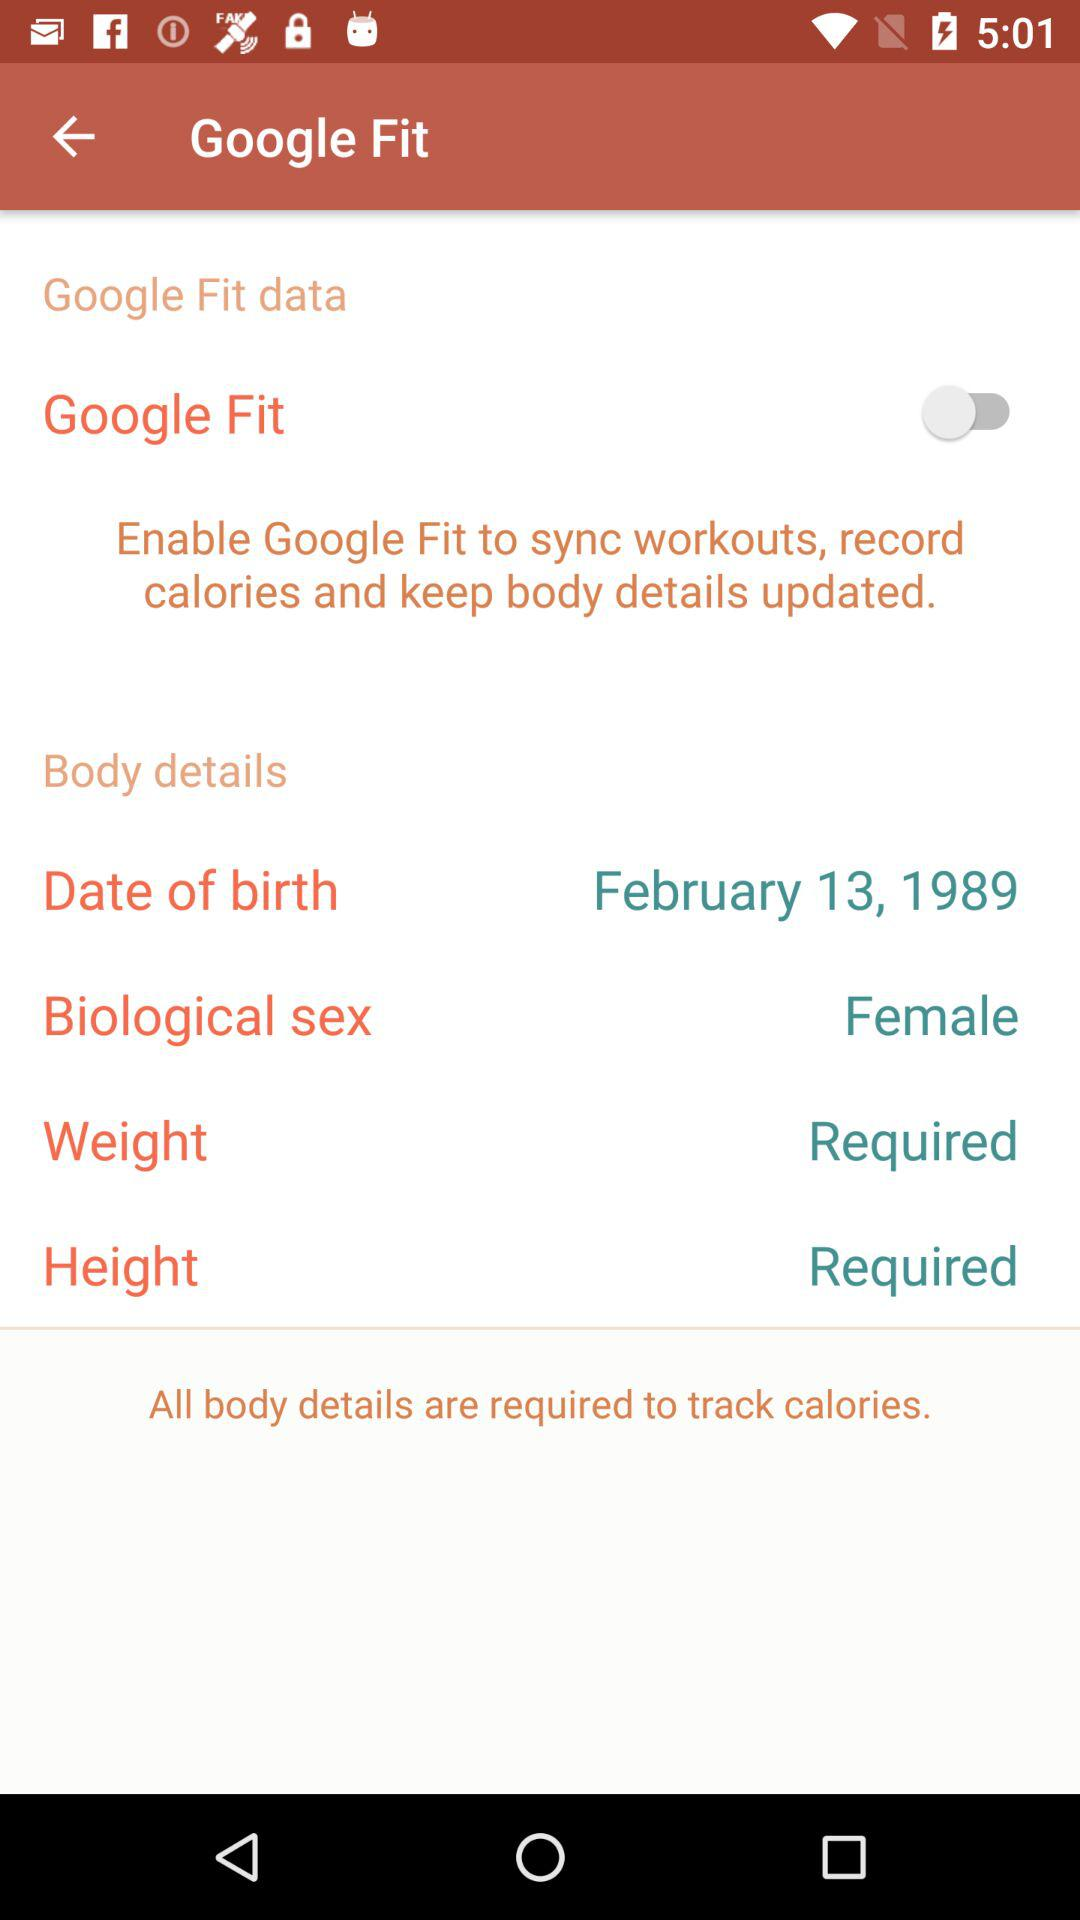What is the status of Google Fit? The status is off. 